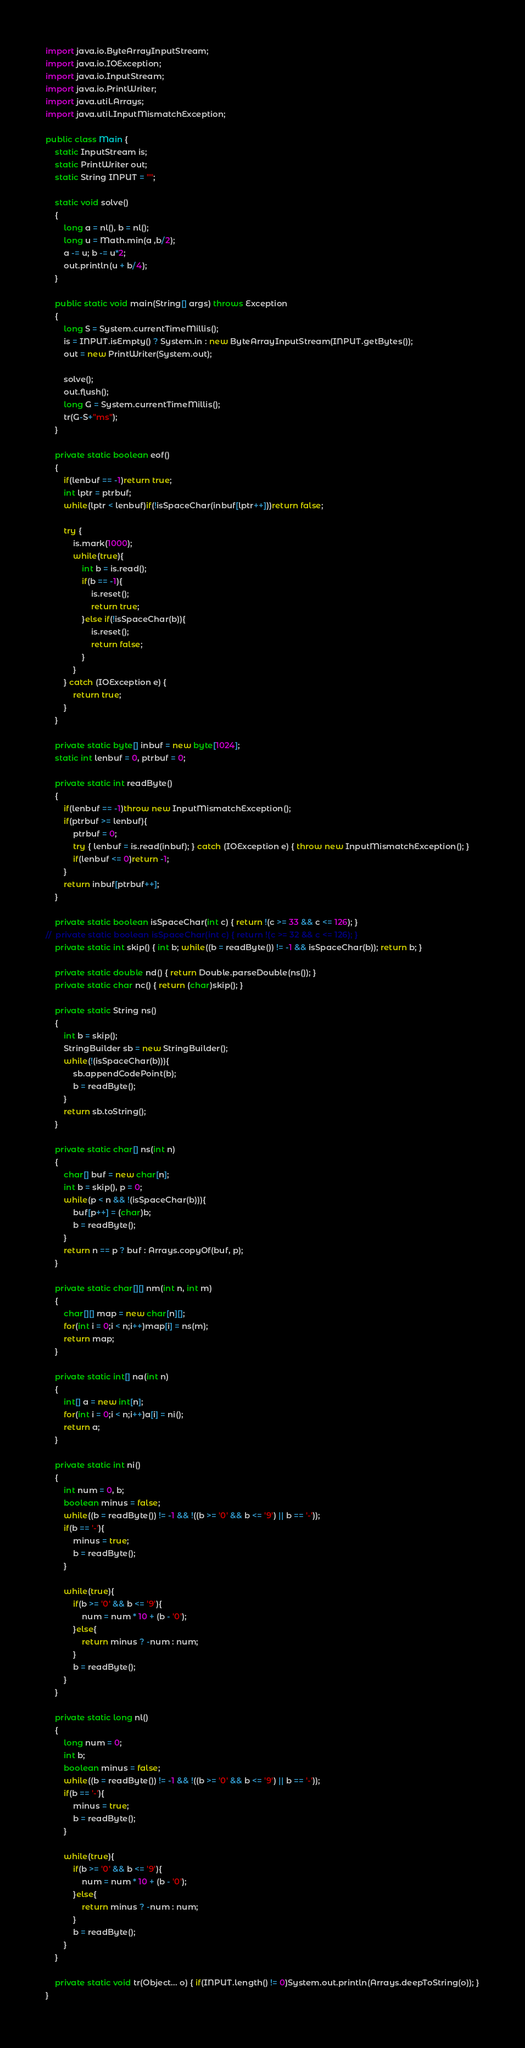Convert code to text. <code><loc_0><loc_0><loc_500><loc_500><_Java_>import java.io.ByteArrayInputStream;
import java.io.IOException;
import java.io.InputStream;
import java.io.PrintWriter;
import java.util.Arrays;
import java.util.InputMismatchException;

public class Main {
	static InputStream is;
	static PrintWriter out;
	static String INPUT = "";
	
	static void solve()
	{
		long a = nl(), b = nl();
		long u = Math.min(a ,b/2);
		a -= u; b -= u*2;
		out.println(u + b/4);
	}
	
	public static void main(String[] args) throws Exception
	{
		long S = System.currentTimeMillis();
		is = INPUT.isEmpty() ? System.in : new ByteArrayInputStream(INPUT.getBytes());
		out = new PrintWriter(System.out);
		
		solve();
		out.flush();
		long G = System.currentTimeMillis();
		tr(G-S+"ms");
	}
	
	private static boolean eof()
	{
		if(lenbuf == -1)return true;
		int lptr = ptrbuf;
		while(lptr < lenbuf)if(!isSpaceChar(inbuf[lptr++]))return false;
		
		try {
			is.mark(1000);
			while(true){
				int b = is.read();
				if(b == -1){
					is.reset();
					return true;
				}else if(!isSpaceChar(b)){
					is.reset();
					return false;
				}
			}
		} catch (IOException e) {
			return true;
		}
	}
	
	private static byte[] inbuf = new byte[1024];
	static int lenbuf = 0, ptrbuf = 0;
	
	private static int readByte()
	{
		if(lenbuf == -1)throw new InputMismatchException();
		if(ptrbuf >= lenbuf){
			ptrbuf = 0;
			try { lenbuf = is.read(inbuf); } catch (IOException e) { throw new InputMismatchException(); }
			if(lenbuf <= 0)return -1;
		}
		return inbuf[ptrbuf++];
	}
	
	private static boolean isSpaceChar(int c) { return !(c >= 33 && c <= 126); }
//	private static boolean isSpaceChar(int c) { return !(c >= 32 && c <= 126); }
	private static int skip() { int b; while((b = readByte()) != -1 && isSpaceChar(b)); return b; }
	
	private static double nd() { return Double.parseDouble(ns()); }
	private static char nc() { return (char)skip(); }
	
	private static String ns()
	{
		int b = skip();
		StringBuilder sb = new StringBuilder();
		while(!(isSpaceChar(b))){
			sb.appendCodePoint(b);
			b = readByte();
		}
		return sb.toString();
	}
	
	private static char[] ns(int n)
	{
		char[] buf = new char[n];
		int b = skip(), p = 0;
		while(p < n && !(isSpaceChar(b))){
			buf[p++] = (char)b;
			b = readByte();
		}
		return n == p ? buf : Arrays.copyOf(buf, p);
	}
	
	private static char[][] nm(int n, int m)
	{
		char[][] map = new char[n][];
		for(int i = 0;i < n;i++)map[i] = ns(m);
		return map;
	}
	
	private static int[] na(int n)
	{
		int[] a = new int[n];
		for(int i = 0;i < n;i++)a[i] = ni();
		return a;
	}
	
	private static int ni()
	{
		int num = 0, b;
		boolean minus = false;
		while((b = readByte()) != -1 && !((b >= '0' && b <= '9') || b == '-'));
		if(b == '-'){
			minus = true;
			b = readByte();
		}
		
		while(true){
			if(b >= '0' && b <= '9'){
				num = num * 10 + (b - '0');
			}else{
				return minus ? -num : num;
			}
			b = readByte();
		}
	}
	
	private static long nl()
	{
		long num = 0;
		int b;
		boolean minus = false;
		while((b = readByte()) != -1 && !((b >= '0' && b <= '9') || b == '-'));
		if(b == '-'){
			minus = true;
			b = readByte();
		}
		
		while(true){
			if(b >= '0' && b <= '9'){
				num = num * 10 + (b - '0');
			}else{
				return minus ? -num : num;
			}
			b = readByte();
		}
	}
	
	private static void tr(Object... o) { if(INPUT.length() != 0)System.out.println(Arrays.deepToString(o)); }
}
</code> 